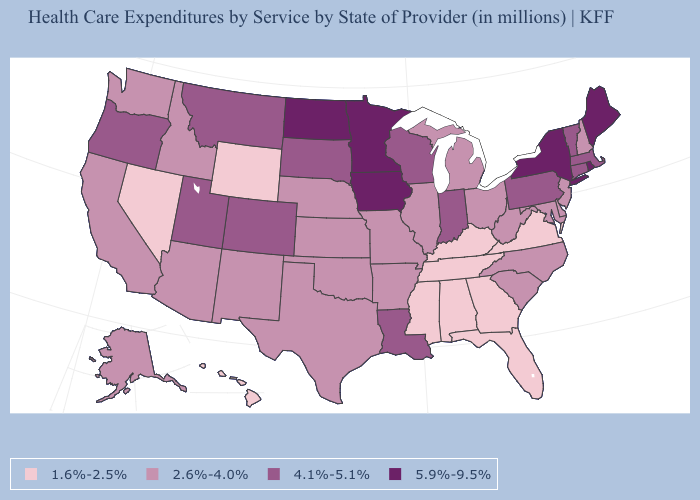Among the states that border Pennsylvania , which have the highest value?
Keep it brief. New York. What is the highest value in the Northeast ?
Concise answer only. 5.9%-9.5%. What is the value of Massachusetts?
Quick response, please. 4.1%-5.1%. Does Pennsylvania have a lower value than Minnesota?
Quick response, please. Yes. Name the states that have a value in the range 5.9%-9.5%?
Give a very brief answer. Iowa, Maine, Minnesota, New York, North Dakota, Rhode Island. What is the value of Oregon?
Short answer required. 4.1%-5.1%. Which states have the lowest value in the USA?
Quick response, please. Alabama, Florida, Georgia, Hawaii, Kentucky, Mississippi, Nevada, Tennessee, Virginia, Wyoming. What is the value of Pennsylvania?
Short answer required. 4.1%-5.1%. What is the value of Indiana?
Concise answer only. 4.1%-5.1%. What is the highest value in the West ?
Short answer required. 4.1%-5.1%. What is the lowest value in states that border Oklahoma?
Write a very short answer. 2.6%-4.0%. What is the value of Florida?
Be succinct. 1.6%-2.5%. Name the states that have a value in the range 2.6%-4.0%?
Answer briefly. Alaska, Arizona, Arkansas, California, Delaware, Idaho, Illinois, Kansas, Maryland, Michigan, Missouri, Nebraska, New Hampshire, New Jersey, New Mexico, North Carolina, Ohio, Oklahoma, South Carolina, Texas, Washington, West Virginia. What is the lowest value in the West?
Write a very short answer. 1.6%-2.5%. Does South Carolina have the lowest value in the South?
Give a very brief answer. No. 